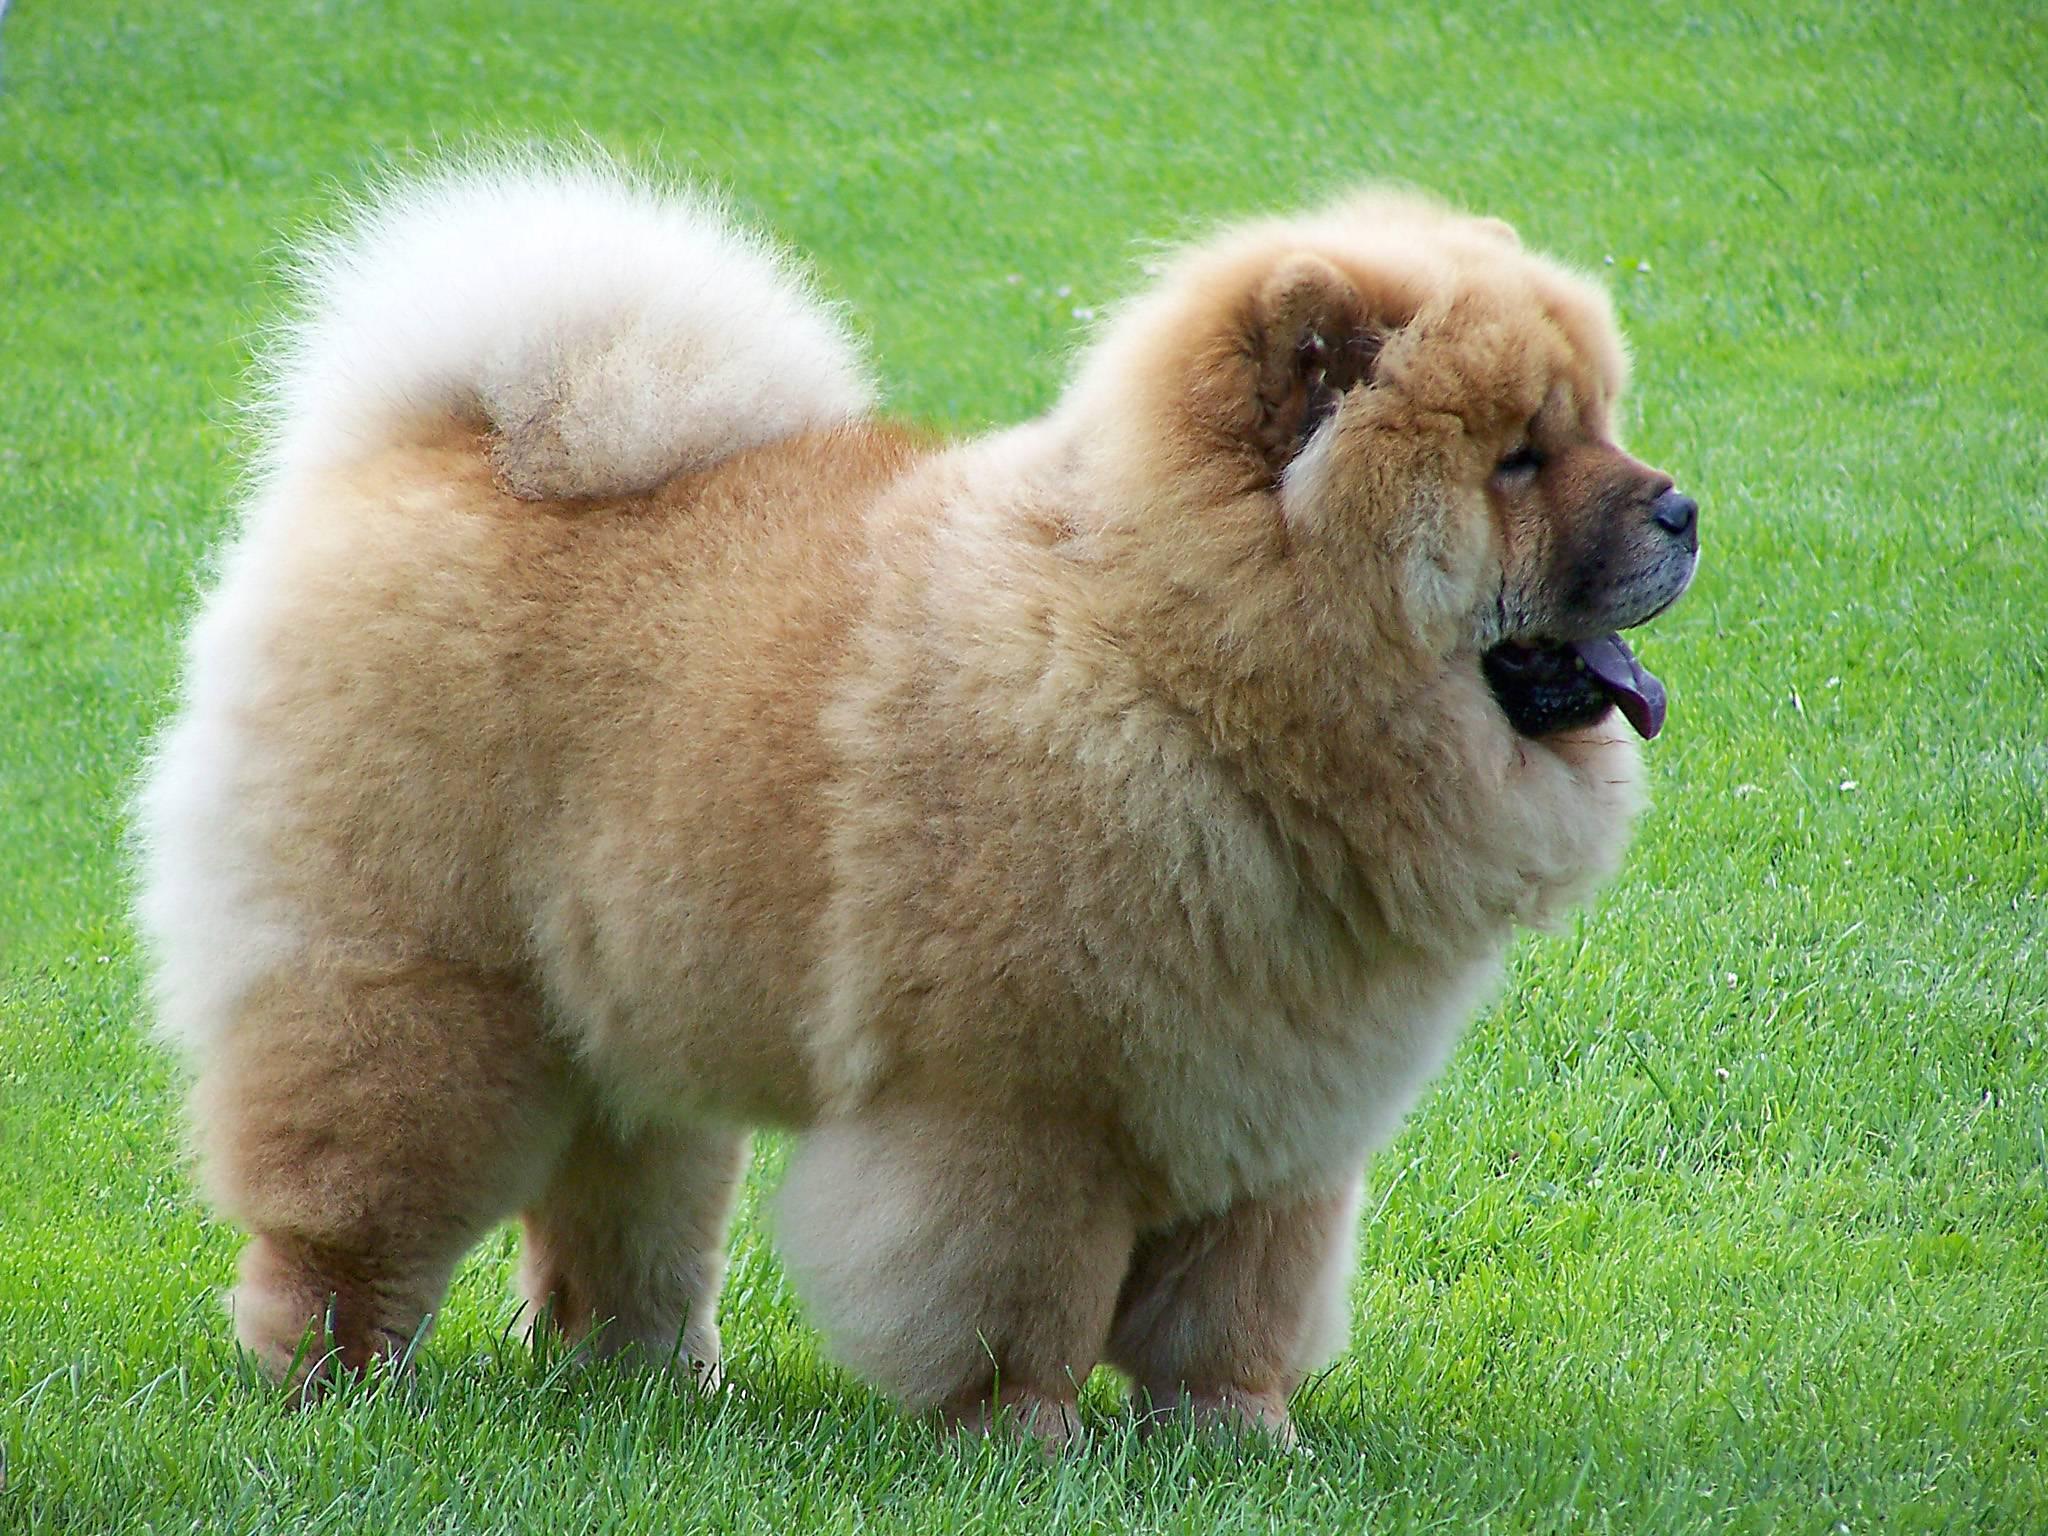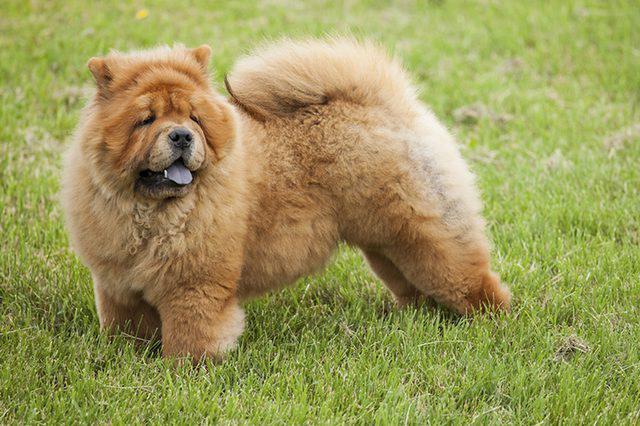The first image is the image on the left, the second image is the image on the right. Analyze the images presented: Is the assertion "The dog in the image on the right is standing on all fours in the grass." valid? Answer yes or no. Yes. The first image is the image on the left, the second image is the image on the right. For the images displayed, is the sentence "All images show exactly one chow dog standing on all fours." factually correct? Answer yes or no. Yes. 